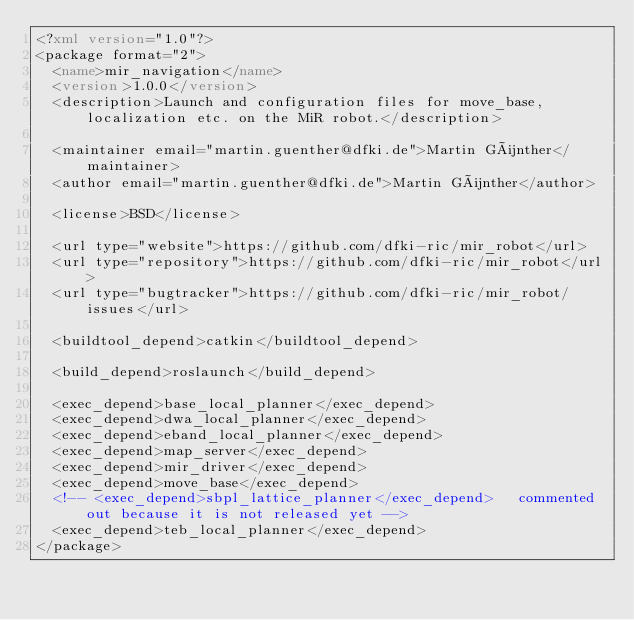Convert code to text. <code><loc_0><loc_0><loc_500><loc_500><_XML_><?xml version="1.0"?>
<package format="2">
  <name>mir_navigation</name>
  <version>1.0.0</version>
  <description>Launch and configuration files for move_base, localization etc. on the MiR robot.</description>

  <maintainer email="martin.guenther@dfki.de">Martin Günther</maintainer>
  <author email="martin.guenther@dfki.de">Martin Günther</author>

  <license>BSD</license>

  <url type="website">https://github.com/dfki-ric/mir_robot</url>
  <url type="repository">https://github.com/dfki-ric/mir_robot</url>
  <url type="bugtracker">https://github.com/dfki-ric/mir_robot/issues</url>

  <buildtool_depend>catkin</buildtool_depend>

  <build_depend>roslaunch</build_depend>

  <exec_depend>base_local_planner</exec_depend>
  <exec_depend>dwa_local_planner</exec_depend>
  <exec_depend>eband_local_planner</exec_depend>
  <exec_depend>map_server</exec_depend>
  <exec_depend>mir_driver</exec_depend>
  <exec_depend>move_base</exec_depend>
  <!-- <exec_depend>sbpl_lattice_planner</exec_depend>   commented out because it is not released yet -->
  <exec_depend>teb_local_planner</exec_depend>
</package>
</code> 